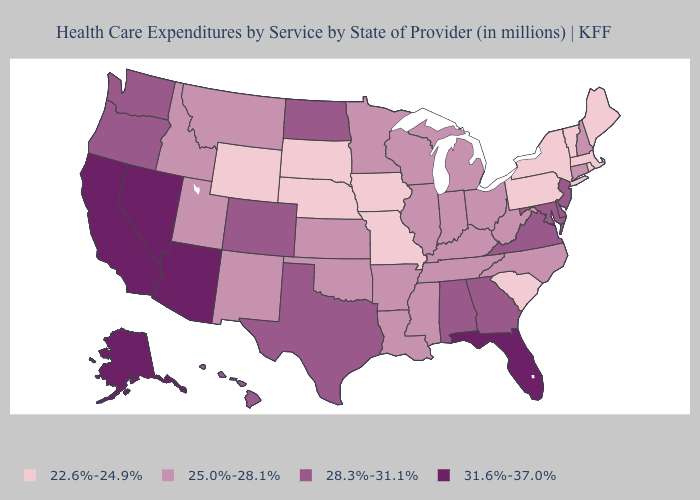Among the states that border Oklahoma , does Missouri have the lowest value?
Short answer required. Yes. Which states hav the highest value in the West?
Concise answer only. Alaska, Arizona, California, Nevada. Does Wyoming have the lowest value in the West?
Keep it brief. Yes. How many symbols are there in the legend?
Be succinct. 4. What is the value of North Carolina?
Quick response, please. 25.0%-28.1%. What is the lowest value in states that border Montana?
Keep it brief. 22.6%-24.9%. What is the lowest value in the West?
Answer briefly. 22.6%-24.9%. What is the value of Rhode Island?
Give a very brief answer. 22.6%-24.9%. Name the states that have a value in the range 25.0%-28.1%?
Concise answer only. Arkansas, Connecticut, Idaho, Illinois, Indiana, Kansas, Kentucky, Louisiana, Michigan, Minnesota, Mississippi, Montana, New Hampshire, New Mexico, North Carolina, Ohio, Oklahoma, Tennessee, Utah, West Virginia, Wisconsin. Name the states that have a value in the range 22.6%-24.9%?
Quick response, please. Iowa, Maine, Massachusetts, Missouri, Nebraska, New York, Pennsylvania, Rhode Island, South Carolina, South Dakota, Vermont, Wyoming. Does North Dakota have the highest value in the MidWest?
Answer briefly. Yes. What is the value of Oregon?
Write a very short answer. 28.3%-31.1%. Which states hav the highest value in the Northeast?
Answer briefly. New Jersey. Does Pennsylvania have the lowest value in the USA?
Quick response, please. Yes. What is the value of New Hampshire?
Keep it brief. 25.0%-28.1%. 